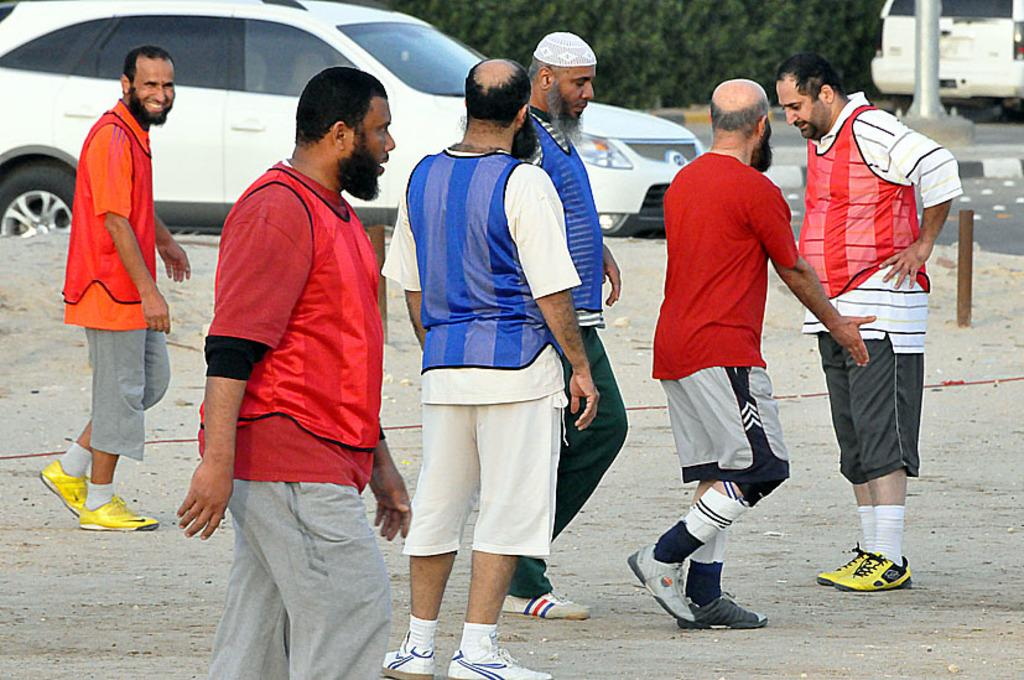What can be seen in the image? There is a group of people in the image. How are the people dressed? The people are wearing different color dresses. What can be seen in the background of the image? There are vehicles and a pole visible in the background, as well as many trees. What type of button is being used to control the sky in the image? There is no button or control for the sky in the image; the sky is simply visible in the background. 